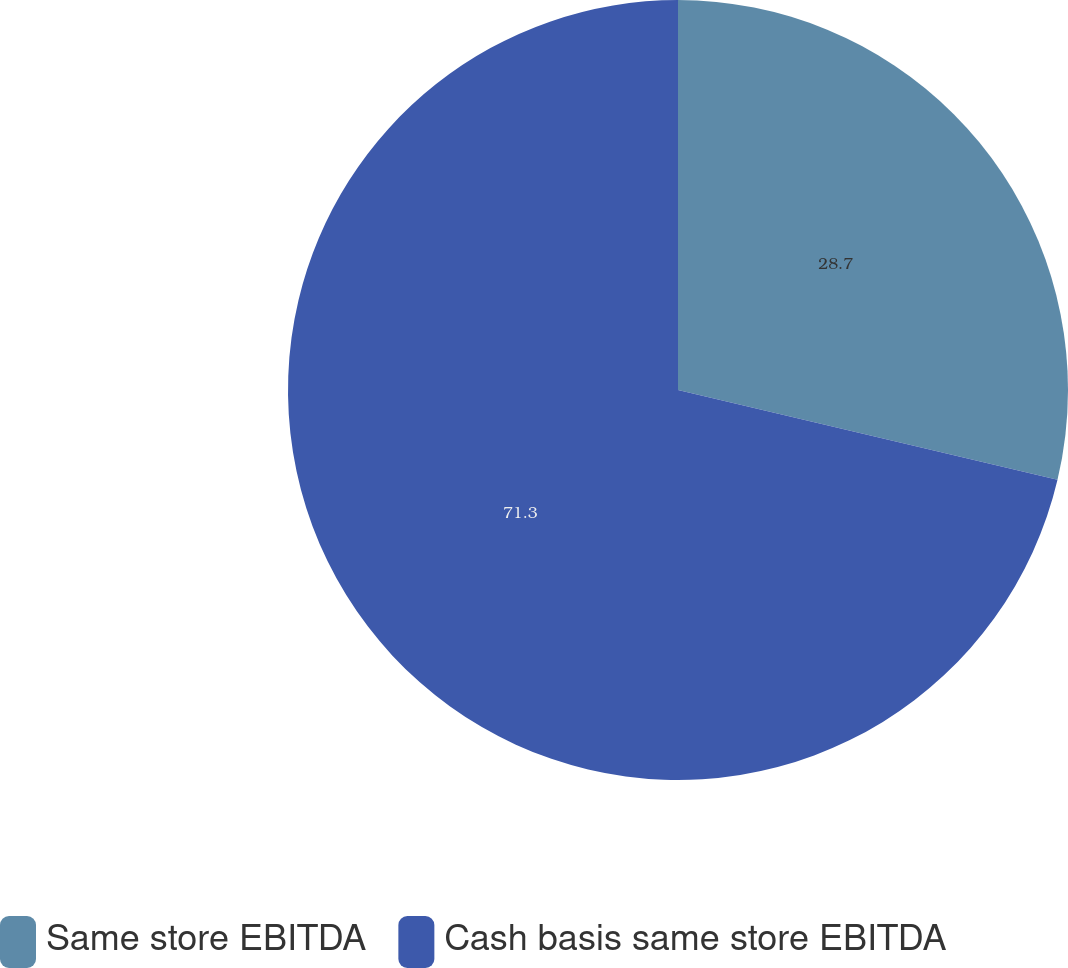Convert chart. <chart><loc_0><loc_0><loc_500><loc_500><pie_chart><fcel>Same store EBITDA<fcel>Cash basis same store EBITDA<nl><fcel>28.7%<fcel>71.3%<nl></chart> 